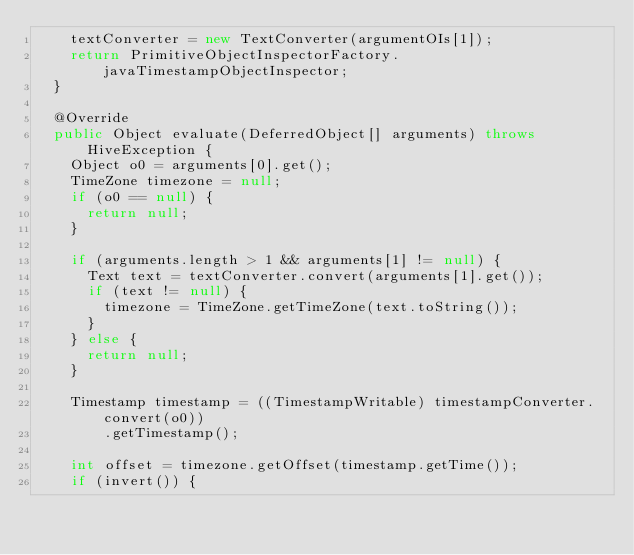Convert code to text. <code><loc_0><loc_0><loc_500><loc_500><_Java_>    textConverter = new TextConverter(argumentOIs[1]);
    return PrimitiveObjectInspectorFactory.javaTimestampObjectInspector;
  }

  @Override
  public Object evaluate(DeferredObject[] arguments) throws HiveException {
    Object o0 = arguments[0].get();
    TimeZone timezone = null;
    if (o0 == null) {
      return null;
    }

    if (arguments.length > 1 && arguments[1] != null) {
      Text text = textConverter.convert(arguments[1].get());
      if (text != null) {
        timezone = TimeZone.getTimeZone(text.toString());
      }
    } else {
      return null;
    }

    Timestamp timestamp = ((TimestampWritable) timestampConverter.convert(o0))
        .getTimestamp();

    int offset = timezone.getOffset(timestamp.getTime());
    if (invert()) {</code> 